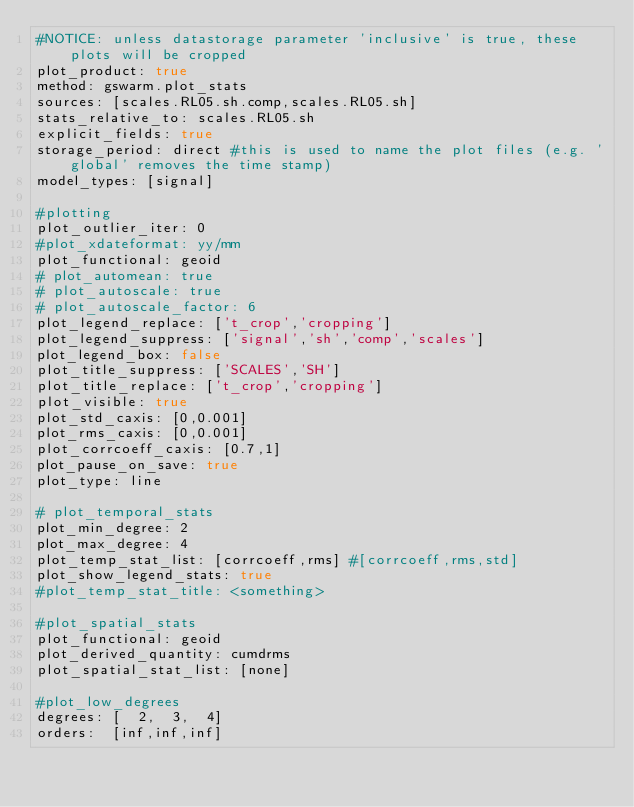Convert code to text. <code><loc_0><loc_0><loc_500><loc_500><_YAML_>#NOTICE: unless datastorage parameter 'inclusive' is true, these plots will be cropped 
plot_product: true
method: gswarm.plot_stats
sources: [scales.RL05.sh.comp,scales.RL05.sh]
stats_relative_to: scales.RL05.sh
explicit_fields: true
storage_period: direct #this is used to name the plot files (e.g. 'global' removes the time stamp)
model_types: [signal]

#plotting
plot_outlier_iter: 0
#plot_xdateformat: yy/mm
plot_functional: geoid
# plot_automean: true
# plot_autoscale: true
# plot_autoscale_factor: 6
plot_legend_replace: ['t_crop','cropping']
plot_legend_suppress: ['signal','sh','comp','scales']
plot_legend_box: false
plot_title_suppress: ['SCALES','SH']
plot_title_replace: ['t_crop','cropping']
plot_visible: true
plot_std_caxis: [0,0.001]
plot_rms_caxis: [0,0.001]
plot_corrcoeff_caxis: [0.7,1]
plot_pause_on_save: true
plot_type: line

# plot_temporal_stats
plot_min_degree: 2
plot_max_degree: 4
plot_temp_stat_list: [corrcoeff,rms] #[corrcoeff,rms,std]
plot_show_legend_stats: true
#plot_temp_stat_title: <something>

#plot_spatial_stats
plot_functional: geoid
plot_derived_quantity: cumdrms
plot_spatial_stat_list: [none]

#plot_low_degrees
degrees: [  2,  3,  4]
orders:  [inf,inf,inf]
</code> 